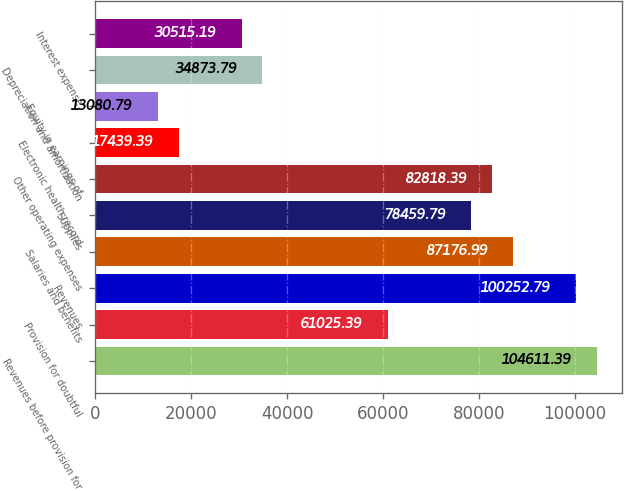Convert chart. <chart><loc_0><loc_0><loc_500><loc_500><bar_chart><fcel>Revenues before provision for<fcel>Provision for doubtful<fcel>Revenues<fcel>Salaries and benefits<fcel>Supplies<fcel>Other operating expenses<fcel>Electronic health record<fcel>Equity in earnings of<fcel>Depreciation and amortization<fcel>Interest expense<nl><fcel>104611<fcel>61025.4<fcel>100253<fcel>87177<fcel>78459.8<fcel>82818.4<fcel>17439.4<fcel>13080.8<fcel>34873.8<fcel>30515.2<nl></chart> 